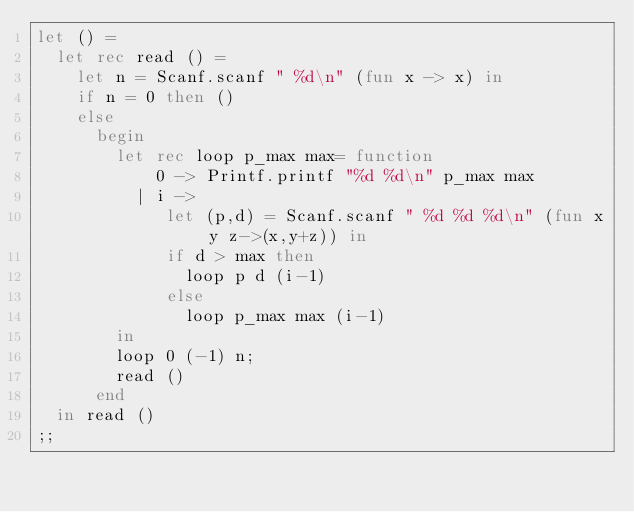Convert code to text. <code><loc_0><loc_0><loc_500><loc_500><_OCaml_>let () =
  let rec read () =
    let n = Scanf.scanf " %d\n" (fun x -> x) in
    if n = 0 then ()
    else
      begin
        let rec loop p_max max= function
            0 -> Printf.printf "%d %d\n" p_max max
          | i ->
             let (p,d) = Scanf.scanf " %d %d %d\n" (fun x y z->(x,y+z)) in
             if d > max then
               loop p d (i-1)
             else
               loop p_max max (i-1)
        in
        loop 0 (-1) n;
        read ()
      end
  in read ()
;;</code> 